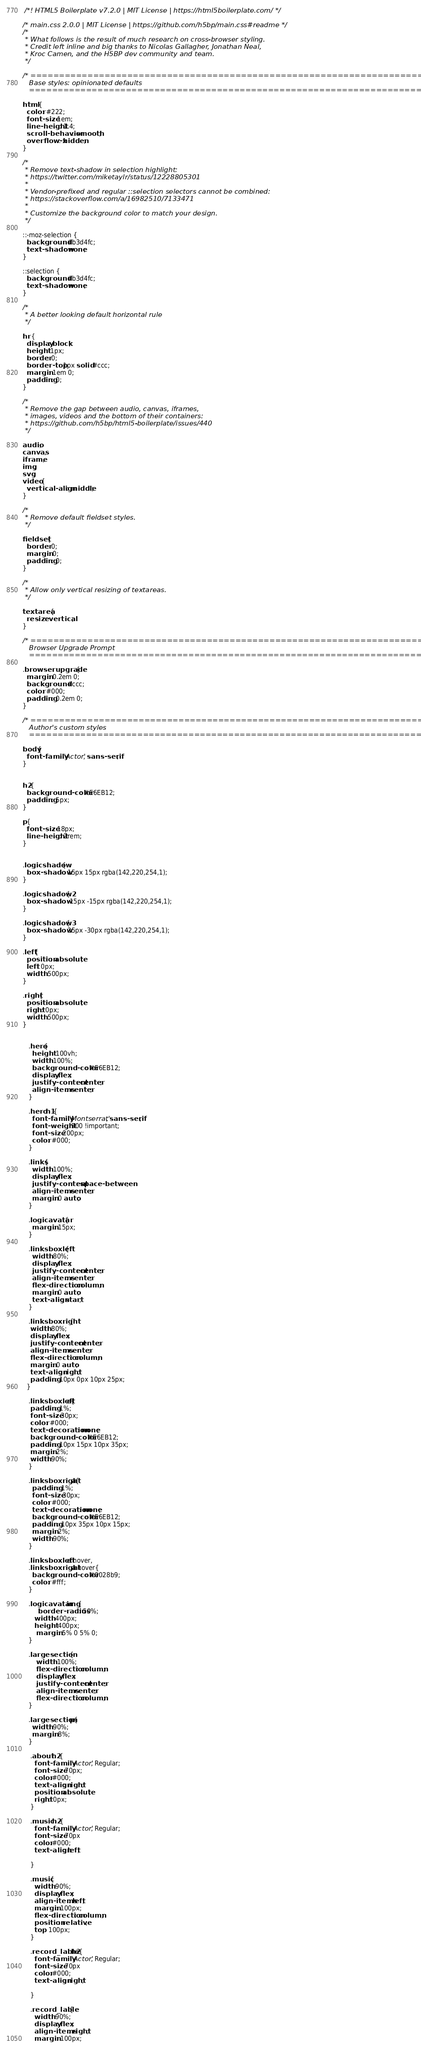Convert code to text. <code><loc_0><loc_0><loc_500><loc_500><_CSS_> /*! HTML5 Boilerplate v7.2.0 | MIT License | https://html5boilerplate.com/ */

/* main.css 2.0.0 | MIT License | https://github.com/h5bp/main.css#readme */
/*
 * What follows is the result of much research on cross-browser styling.
 * Credit left inline and big thanks to Nicolas Gallagher, Jonathan Neal,
 * Kroc Camen, and the H5BP dev community and team.
 */

/* ==========================================================================
   Base styles: opinionated defaults
   ========================================================================== */

html {
  color: #222;
  font-size: 1em;
  line-height: 1.4;
  scroll-behavior: smooth;
  overflow-x: hidden;
}

/*
 * Remove text-shadow in selection highlight:
 * https://twitter.com/miketaylr/status/12228805301
 *
 * Vendor-prefixed and regular ::selection selectors cannot be combined:
 * https://stackoverflow.com/a/16982510/7133471
 *
 * Customize the background color to match your design.
 */

::-moz-selection {
  background: #b3d4fc;
  text-shadow: none;
}

::selection {
  background: #b3d4fc;
  text-shadow: none;
}

/*
 * A better looking default horizontal rule
 */

hr {
  display: block;
  height: 1px;
  border: 0;
  border-top: 1px solid #ccc;
  margin: 1em 0;
  padding: 0;
}

/*
 * Remove the gap between audio, canvas, iframes,
 * images, videos and the bottom of their containers:
 * https://github.com/h5bp/html5-boilerplate/issues/440
 */

audio,
canvas,
iframe,
img,
svg,
video {
  vertical-align: middle;
}

/*
 * Remove default fieldset styles.
 */

fieldset {
  border: 0;
  margin: 0;
  padding: 0;
}

/*
 * Allow only vertical resizing of textareas.
 */

textarea {
  resize: vertical;
}

/* ==========================================================================
   Browser Upgrade Prompt
   ========================================================================== */

.browserupgrade {
  margin: 0.2em 0;
  background: #ccc;
  color: #000;
  padding: 0.2em 0;
}

/* ==========================================================================
   Author's custom styles
   ========================================================================== */

body{
  font-family: 'Actor', sans-serif;
}


h2{
  background-color: #E6EB12;
  padding: 5px;
}

p{
  font-size: 18px;
  line-height: 2rem;
}


.logicshadow{
  box-shadow: 15px 15px rgba(142,220,254,1);
}

.logicshadow2{
  box-shadow: -15px -15px rgba(142,220,254,1);
}

.logicshadow3{
  box-shadow: 25px -30px rgba(142,220,254,1);
}

.left{
  position: absolute;
  left: 0px;
  width: 500px;
}

.right{
  position: absolute;
  right: 0px;
  width: 500px;
}


   .hero{
     height: 100vh;
     width: 100%;
     background-color: #E6EB12;
     display: flex;
     justify-content: center;
     align-items: center;
   }

   .hero h1{
     font-family: 'Montserrat', sans-serif;
     font-weight: 900 !important;
     font-size: 200px;
     color: #000;
   }

   .links{
     width: 100%;
     display: flex;
     justify-content: space-between;
     align-items: center;
     margin: 0 auto;
   }

   .logicavatar{
     margin: 15px;
   }

   .linksboxleft{
     width: 80%;
     display: flex;
     justify-content: center;
     align-items: center;
     flex-direction: column;
     margin: 0 auto;
     text-align: start;
   }

   .linksboxright{
    width: 80%;
    display: flex;
    justify-content: center;
    align-items: center;
    flex-direction: column;
    margin: 0 auto;
    text-align: right;
    padding: 10px 0px 10px 25px;
  }

   .linksboxleft a{
    padding: 1%;
    font-size: 30px;
    color: #000;
    text-decoration: none;
    background-color: #E6EB12;
    padding: 10px 15px 10px 35px;
    margin: 2%;
    width: 90%;
   }

   .linksboxright a{
     padding: 1%;
     font-size: 30px;
     color: #000;
     text-decoration: none;
     background-color: #E6EB12;
     padding: 10px 35px 10px 15px;
     margin: 2%;
     width: 90%;
   }

   .linksboxleft a:hover,
   .linksboxright a:hover{
     background-color: #0028b9;
     color: #fff;
   }

   .logicavatar img{
     	border-radius: 50%;
      width: 400px;
      height: 400px;
       margin: 5% 0 5% 0;
   }

   .largesection {
       width: 100%;
       flex-direction: column;
       display: flex;
       justify-content: center;
       align-items: center;
       flex-direction: column;
   }

   .largesection p{
     width: 90%;
     margin: 8%;
   }

    .about h2{
      font-family: 'Actor', Regular;
      font-size: 70px;
      color:#000;
      text-align: right;
      position: absolute;
      right: 0px;
    }

    .music h2{
      font-family: 'Actor', Regular;
      font-size: 70px
      color:#000;
      text-align: left;

    }

    .music{
      width: 90%;
      display: flex;
      align-items: left;
      margin: 100px;
      flex-direction: column;
      position: relative;
      top: 100px;
    }

    .record_lable h2{
      font-family: 'Actor', Regular;
      font-size: 70px
      color:#000;
      text-align: right;

    }

    .record_lable{
      width: 90%;
      display: flex;
      align-items: right;
      margin: 100px;</code> 